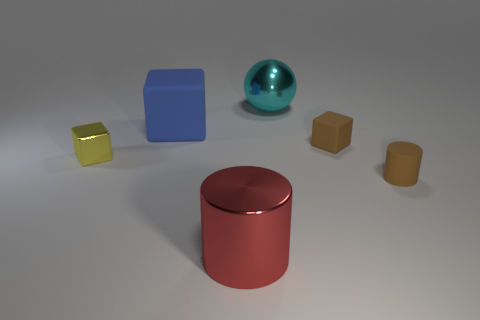Which objects in the image have reflective surfaces? The sphere and the two cylinders appear to have reflective surfaces, as indicated by the visible highlights and the way they interact with light in the image. 